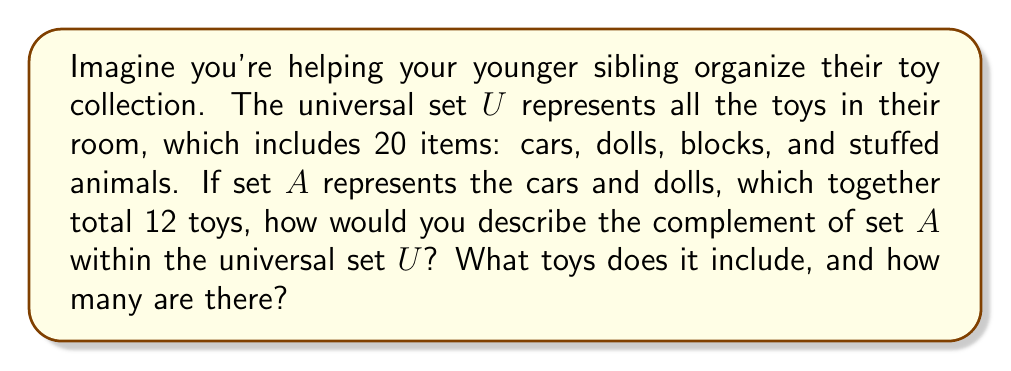Give your solution to this math problem. Let's approach this step-by-step:

1) First, let's define our sets:
   $U$ = Universal set (all toys in the room)
   $A$ = Set of cars and dolls

2) We're given that:
   $|U| = 20$ (total number of toys)
   $|A| = 12$ (number of cars and dolls)

3) The complement of set $A$, denoted as $A^c$ or $U - A$, includes all elements in the universal set $U$ that are not in set $A$.

4) To find the number of elements in $A^c$, we can use the formula:
   $|A^c| = |U| - |A|$

5) Substituting the values:
   $|A^c| = 20 - 12 = 8$

6) Now, we know that $A^c$ contains 8 toys. 

7) Since $A$ contains cars and dolls, $A^c$ must contain the remaining types of toys: blocks and stuffed animals.

Therefore, $A^c$ represents the set of blocks and stuffed animals, which total 8 toys.
Answer: The complement of set $A$ ($A^c$) consists of blocks and stuffed animals, and contains 8 toys. 